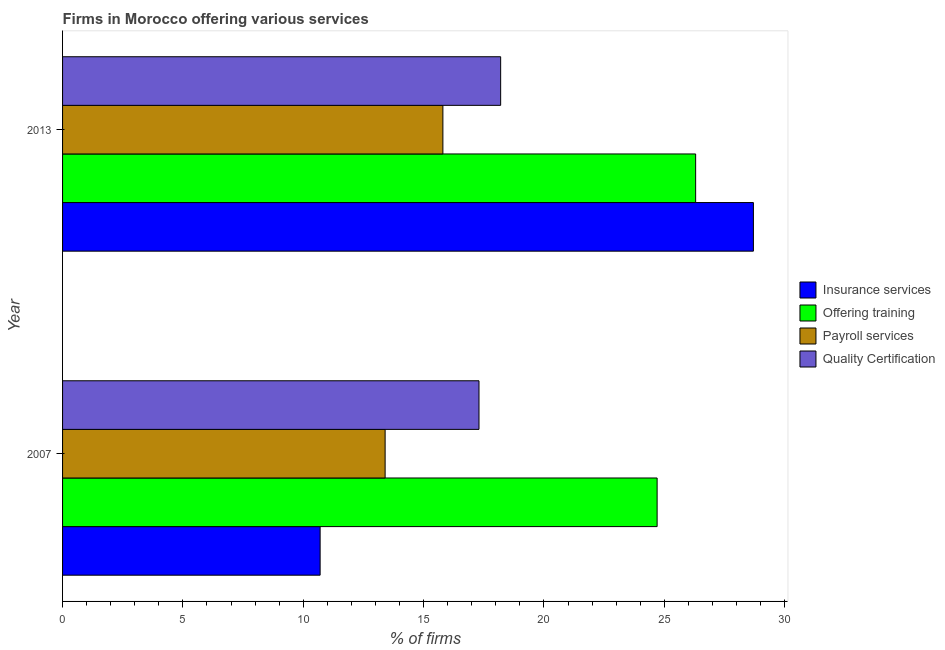How many groups of bars are there?
Ensure brevity in your answer.  2. Are the number of bars on each tick of the Y-axis equal?
Ensure brevity in your answer.  Yes. How many bars are there on the 2nd tick from the bottom?
Keep it short and to the point. 4. What is the label of the 1st group of bars from the top?
Ensure brevity in your answer.  2013. What is the percentage of firms offering training in 2007?
Ensure brevity in your answer.  24.7. Across all years, what is the maximum percentage of firms offering quality certification?
Provide a short and direct response. 18.2. Across all years, what is the minimum percentage of firms offering payroll services?
Keep it short and to the point. 13.4. In which year was the percentage of firms offering quality certification minimum?
Offer a very short reply. 2007. What is the total percentage of firms offering training in the graph?
Your response must be concise. 51. What is the difference between the percentage of firms offering insurance services in 2007 and that in 2013?
Provide a succinct answer. -18. What is the difference between the percentage of firms offering quality certification in 2013 and the percentage of firms offering payroll services in 2007?
Provide a succinct answer. 4.8. What is the average percentage of firms offering payroll services per year?
Your answer should be very brief. 14.6. What is the ratio of the percentage of firms offering training in 2007 to that in 2013?
Keep it short and to the point. 0.94. In how many years, is the percentage of firms offering training greater than the average percentage of firms offering training taken over all years?
Your answer should be compact. 1. What does the 2nd bar from the top in 2007 represents?
Offer a very short reply. Payroll services. What does the 3rd bar from the bottom in 2013 represents?
Provide a short and direct response. Payroll services. Is it the case that in every year, the sum of the percentage of firms offering insurance services and percentage of firms offering training is greater than the percentage of firms offering payroll services?
Offer a terse response. Yes. How many bars are there?
Make the answer very short. 8. Are the values on the major ticks of X-axis written in scientific E-notation?
Your answer should be very brief. No. Does the graph contain any zero values?
Provide a short and direct response. No. Where does the legend appear in the graph?
Keep it short and to the point. Center right. How many legend labels are there?
Provide a succinct answer. 4. How are the legend labels stacked?
Ensure brevity in your answer.  Vertical. What is the title of the graph?
Keep it short and to the point. Firms in Morocco offering various services . What is the label or title of the X-axis?
Your response must be concise. % of firms. What is the % of firms in Insurance services in 2007?
Provide a short and direct response. 10.7. What is the % of firms in Offering training in 2007?
Give a very brief answer. 24.7. What is the % of firms in Quality Certification in 2007?
Ensure brevity in your answer.  17.3. What is the % of firms in Insurance services in 2013?
Provide a short and direct response. 28.7. What is the % of firms in Offering training in 2013?
Your answer should be compact. 26.3. Across all years, what is the maximum % of firms of Insurance services?
Ensure brevity in your answer.  28.7. Across all years, what is the maximum % of firms of Offering training?
Offer a terse response. 26.3. Across all years, what is the maximum % of firms in Payroll services?
Ensure brevity in your answer.  15.8. Across all years, what is the minimum % of firms of Offering training?
Make the answer very short. 24.7. Across all years, what is the minimum % of firms in Payroll services?
Give a very brief answer. 13.4. What is the total % of firms of Insurance services in the graph?
Give a very brief answer. 39.4. What is the total % of firms of Offering training in the graph?
Provide a short and direct response. 51. What is the total % of firms in Payroll services in the graph?
Keep it short and to the point. 29.2. What is the total % of firms of Quality Certification in the graph?
Your response must be concise. 35.5. What is the difference between the % of firms in Insurance services in 2007 and that in 2013?
Offer a very short reply. -18. What is the difference between the % of firms of Quality Certification in 2007 and that in 2013?
Offer a very short reply. -0.9. What is the difference between the % of firms of Insurance services in 2007 and the % of firms of Offering training in 2013?
Make the answer very short. -15.6. What is the difference between the % of firms of Insurance services in 2007 and the % of firms of Payroll services in 2013?
Provide a short and direct response. -5.1. What is the difference between the % of firms in Insurance services in 2007 and the % of firms in Quality Certification in 2013?
Your answer should be very brief. -7.5. What is the difference between the % of firms of Offering training in 2007 and the % of firms of Payroll services in 2013?
Your answer should be very brief. 8.9. What is the average % of firms of Quality Certification per year?
Offer a very short reply. 17.75. In the year 2007, what is the difference between the % of firms of Insurance services and % of firms of Payroll services?
Provide a short and direct response. -2.7. In the year 2007, what is the difference between the % of firms in Insurance services and % of firms in Quality Certification?
Keep it short and to the point. -6.6. In the year 2013, what is the difference between the % of firms of Insurance services and % of firms of Offering training?
Your response must be concise. 2.4. In the year 2013, what is the difference between the % of firms of Insurance services and % of firms of Payroll services?
Offer a terse response. 12.9. In the year 2013, what is the difference between the % of firms in Offering training and % of firms in Quality Certification?
Your answer should be very brief. 8.1. In the year 2013, what is the difference between the % of firms of Payroll services and % of firms of Quality Certification?
Your response must be concise. -2.4. What is the ratio of the % of firms of Insurance services in 2007 to that in 2013?
Make the answer very short. 0.37. What is the ratio of the % of firms in Offering training in 2007 to that in 2013?
Provide a short and direct response. 0.94. What is the ratio of the % of firms of Payroll services in 2007 to that in 2013?
Ensure brevity in your answer.  0.85. What is the ratio of the % of firms in Quality Certification in 2007 to that in 2013?
Give a very brief answer. 0.95. What is the difference between the highest and the second highest % of firms of Offering training?
Provide a succinct answer. 1.6. What is the difference between the highest and the second highest % of firms in Quality Certification?
Make the answer very short. 0.9. 